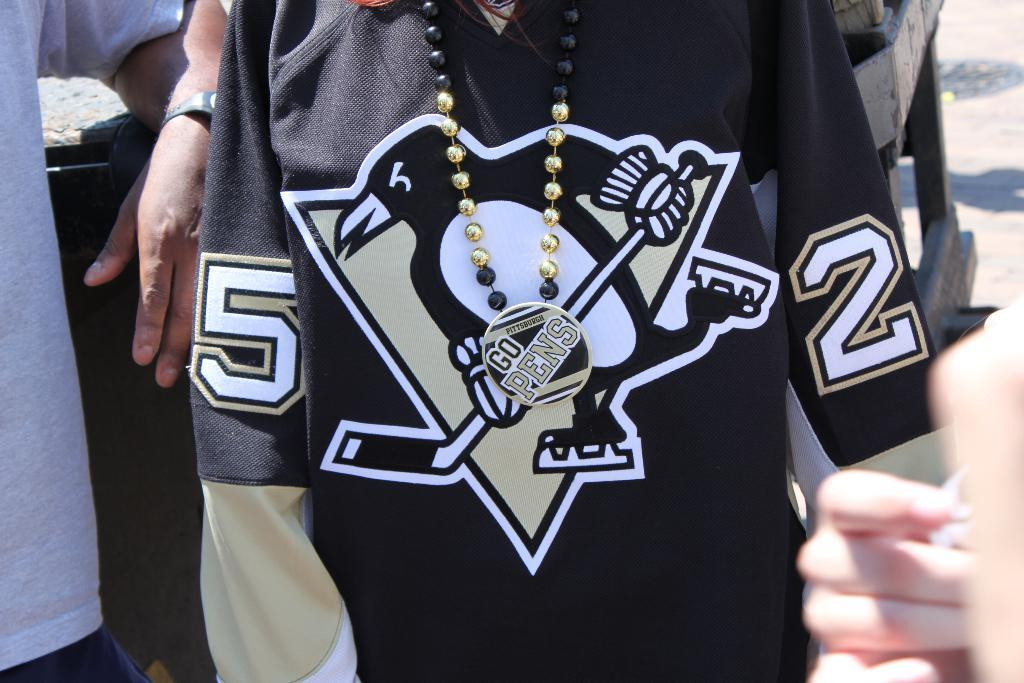<image>
Render a clear and concise summary of the photo. Person wearing a hockey jersey that shows a picture of a penguin and has #5 on the left sleeve and #2 on the right sleeve. 